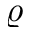Convert formula to latex. <formula><loc_0><loc_0><loc_500><loc_500>\varrho</formula> 